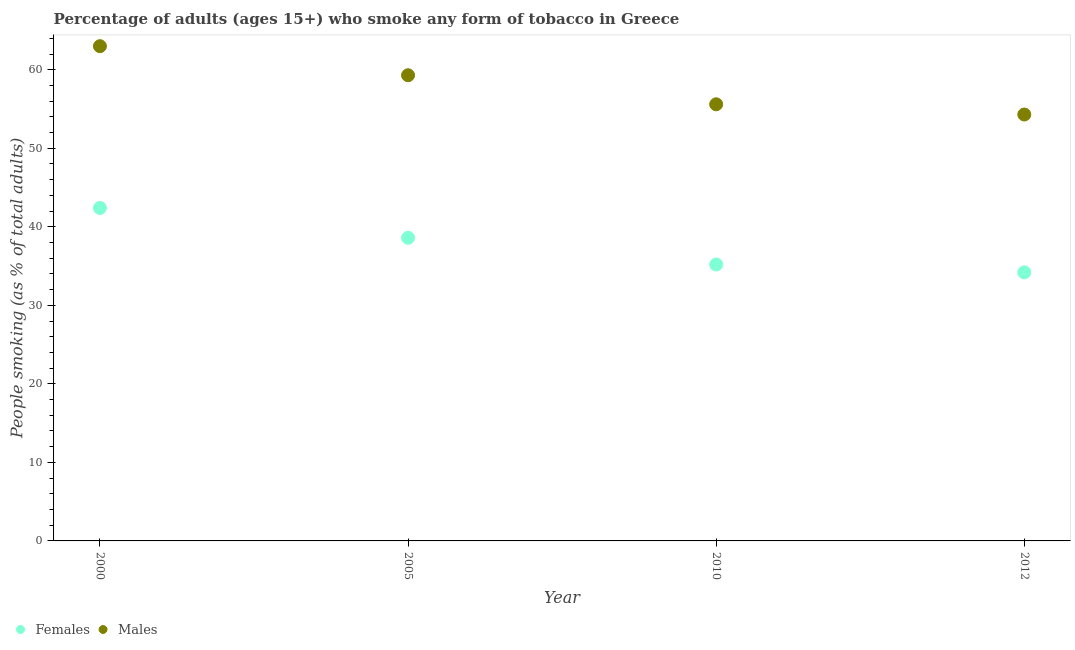Is the number of dotlines equal to the number of legend labels?
Your answer should be very brief. Yes. What is the percentage of females who smoke in 2005?
Ensure brevity in your answer.  38.6. Across all years, what is the maximum percentage of females who smoke?
Provide a short and direct response. 42.4. Across all years, what is the minimum percentage of males who smoke?
Ensure brevity in your answer.  54.3. In which year was the percentage of females who smoke minimum?
Keep it short and to the point. 2012. What is the total percentage of males who smoke in the graph?
Your answer should be very brief. 232.2. What is the difference between the percentage of females who smoke in 2005 and that in 2010?
Give a very brief answer. 3.4. What is the difference between the percentage of females who smoke in 2012 and the percentage of males who smoke in 2005?
Provide a short and direct response. -25.1. What is the average percentage of males who smoke per year?
Make the answer very short. 58.05. In the year 2012, what is the difference between the percentage of females who smoke and percentage of males who smoke?
Offer a terse response. -20.1. In how many years, is the percentage of females who smoke greater than 26 %?
Offer a very short reply. 4. What is the ratio of the percentage of females who smoke in 2005 to that in 2010?
Ensure brevity in your answer.  1.1. Is the difference between the percentage of females who smoke in 2005 and 2010 greater than the difference between the percentage of males who smoke in 2005 and 2010?
Provide a succinct answer. No. What is the difference between the highest and the second highest percentage of males who smoke?
Offer a terse response. 3.7. What is the difference between the highest and the lowest percentage of females who smoke?
Ensure brevity in your answer.  8.2. Are the values on the major ticks of Y-axis written in scientific E-notation?
Offer a very short reply. No. Does the graph contain any zero values?
Keep it short and to the point. No. Does the graph contain grids?
Give a very brief answer. No. How are the legend labels stacked?
Your answer should be compact. Horizontal. What is the title of the graph?
Your answer should be compact. Percentage of adults (ages 15+) who smoke any form of tobacco in Greece. What is the label or title of the Y-axis?
Give a very brief answer. People smoking (as % of total adults). What is the People smoking (as % of total adults) in Females in 2000?
Your answer should be very brief. 42.4. What is the People smoking (as % of total adults) in Females in 2005?
Provide a short and direct response. 38.6. What is the People smoking (as % of total adults) of Males in 2005?
Your answer should be compact. 59.3. What is the People smoking (as % of total adults) of Females in 2010?
Give a very brief answer. 35.2. What is the People smoking (as % of total adults) of Males in 2010?
Your response must be concise. 55.6. What is the People smoking (as % of total adults) in Females in 2012?
Give a very brief answer. 34.2. What is the People smoking (as % of total adults) in Males in 2012?
Make the answer very short. 54.3. Across all years, what is the maximum People smoking (as % of total adults) of Females?
Your response must be concise. 42.4. Across all years, what is the minimum People smoking (as % of total adults) of Females?
Keep it short and to the point. 34.2. Across all years, what is the minimum People smoking (as % of total adults) in Males?
Provide a succinct answer. 54.3. What is the total People smoking (as % of total adults) in Females in the graph?
Offer a terse response. 150.4. What is the total People smoking (as % of total adults) in Males in the graph?
Keep it short and to the point. 232.2. What is the difference between the People smoking (as % of total adults) of Females in 2000 and that in 2012?
Your response must be concise. 8.2. What is the difference between the People smoking (as % of total adults) of Males in 2005 and that in 2012?
Provide a short and direct response. 5. What is the difference between the People smoking (as % of total adults) in Females in 2010 and that in 2012?
Ensure brevity in your answer.  1. What is the difference between the People smoking (as % of total adults) of Females in 2000 and the People smoking (as % of total adults) of Males in 2005?
Give a very brief answer. -16.9. What is the difference between the People smoking (as % of total adults) in Females in 2000 and the People smoking (as % of total adults) in Males in 2010?
Offer a very short reply. -13.2. What is the difference between the People smoking (as % of total adults) of Females in 2005 and the People smoking (as % of total adults) of Males in 2012?
Your answer should be very brief. -15.7. What is the difference between the People smoking (as % of total adults) of Females in 2010 and the People smoking (as % of total adults) of Males in 2012?
Keep it short and to the point. -19.1. What is the average People smoking (as % of total adults) of Females per year?
Your response must be concise. 37.6. What is the average People smoking (as % of total adults) in Males per year?
Keep it short and to the point. 58.05. In the year 2000, what is the difference between the People smoking (as % of total adults) of Females and People smoking (as % of total adults) of Males?
Your answer should be compact. -20.6. In the year 2005, what is the difference between the People smoking (as % of total adults) in Females and People smoking (as % of total adults) in Males?
Your response must be concise. -20.7. In the year 2010, what is the difference between the People smoking (as % of total adults) in Females and People smoking (as % of total adults) in Males?
Provide a short and direct response. -20.4. In the year 2012, what is the difference between the People smoking (as % of total adults) of Females and People smoking (as % of total adults) of Males?
Provide a succinct answer. -20.1. What is the ratio of the People smoking (as % of total adults) of Females in 2000 to that in 2005?
Give a very brief answer. 1.1. What is the ratio of the People smoking (as % of total adults) of Males in 2000 to that in 2005?
Keep it short and to the point. 1.06. What is the ratio of the People smoking (as % of total adults) in Females in 2000 to that in 2010?
Your answer should be compact. 1.2. What is the ratio of the People smoking (as % of total adults) in Males in 2000 to that in 2010?
Make the answer very short. 1.13. What is the ratio of the People smoking (as % of total adults) in Females in 2000 to that in 2012?
Provide a succinct answer. 1.24. What is the ratio of the People smoking (as % of total adults) in Males in 2000 to that in 2012?
Provide a short and direct response. 1.16. What is the ratio of the People smoking (as % of total adults) in Females in 2005 to that in 2010?
Provide a short and direct response. 1.1. What is the ratio of the People smoking (as % of total adults) of Males in 2005 to that in 2010?
Provide a short and direct response. 1.07. What is the ratio of the People smoking (as % of total adults) in Females in 2005 to that in 2012?
Provide a succinct answer. 1.13. What is the ratio of the People smoking (as % of total adults) in Males in 2005 to that in 2012?
Provide a succinct answer. 1.09. What is the ratio of the People smoking (as % of total adults) of Females in 2010 to that in 2012?
Provide a short and direct response. 1.03. What is the ratio of the People smoking (as % of total adults) in Males in 2010 to that in 2012?
Offer a very short reply. 1.02. What is the difference between the highest and the second highest People smoking (as % of total adults) of Females?
Keep it short and to the point. 3.8. What is the difference between the highest and the second highest People smoking (as % of total adults) in Males?
Keep it short and to the point. 3.7. What is the difference between the highest and the lowest People smoking (as % of total adults) in Females?
Provide a succinct answer. 8.2. What is the difference between the highest and the lowest People smoking (as % of total adults) of Males?
Provide a succinct answer. 8.7. 